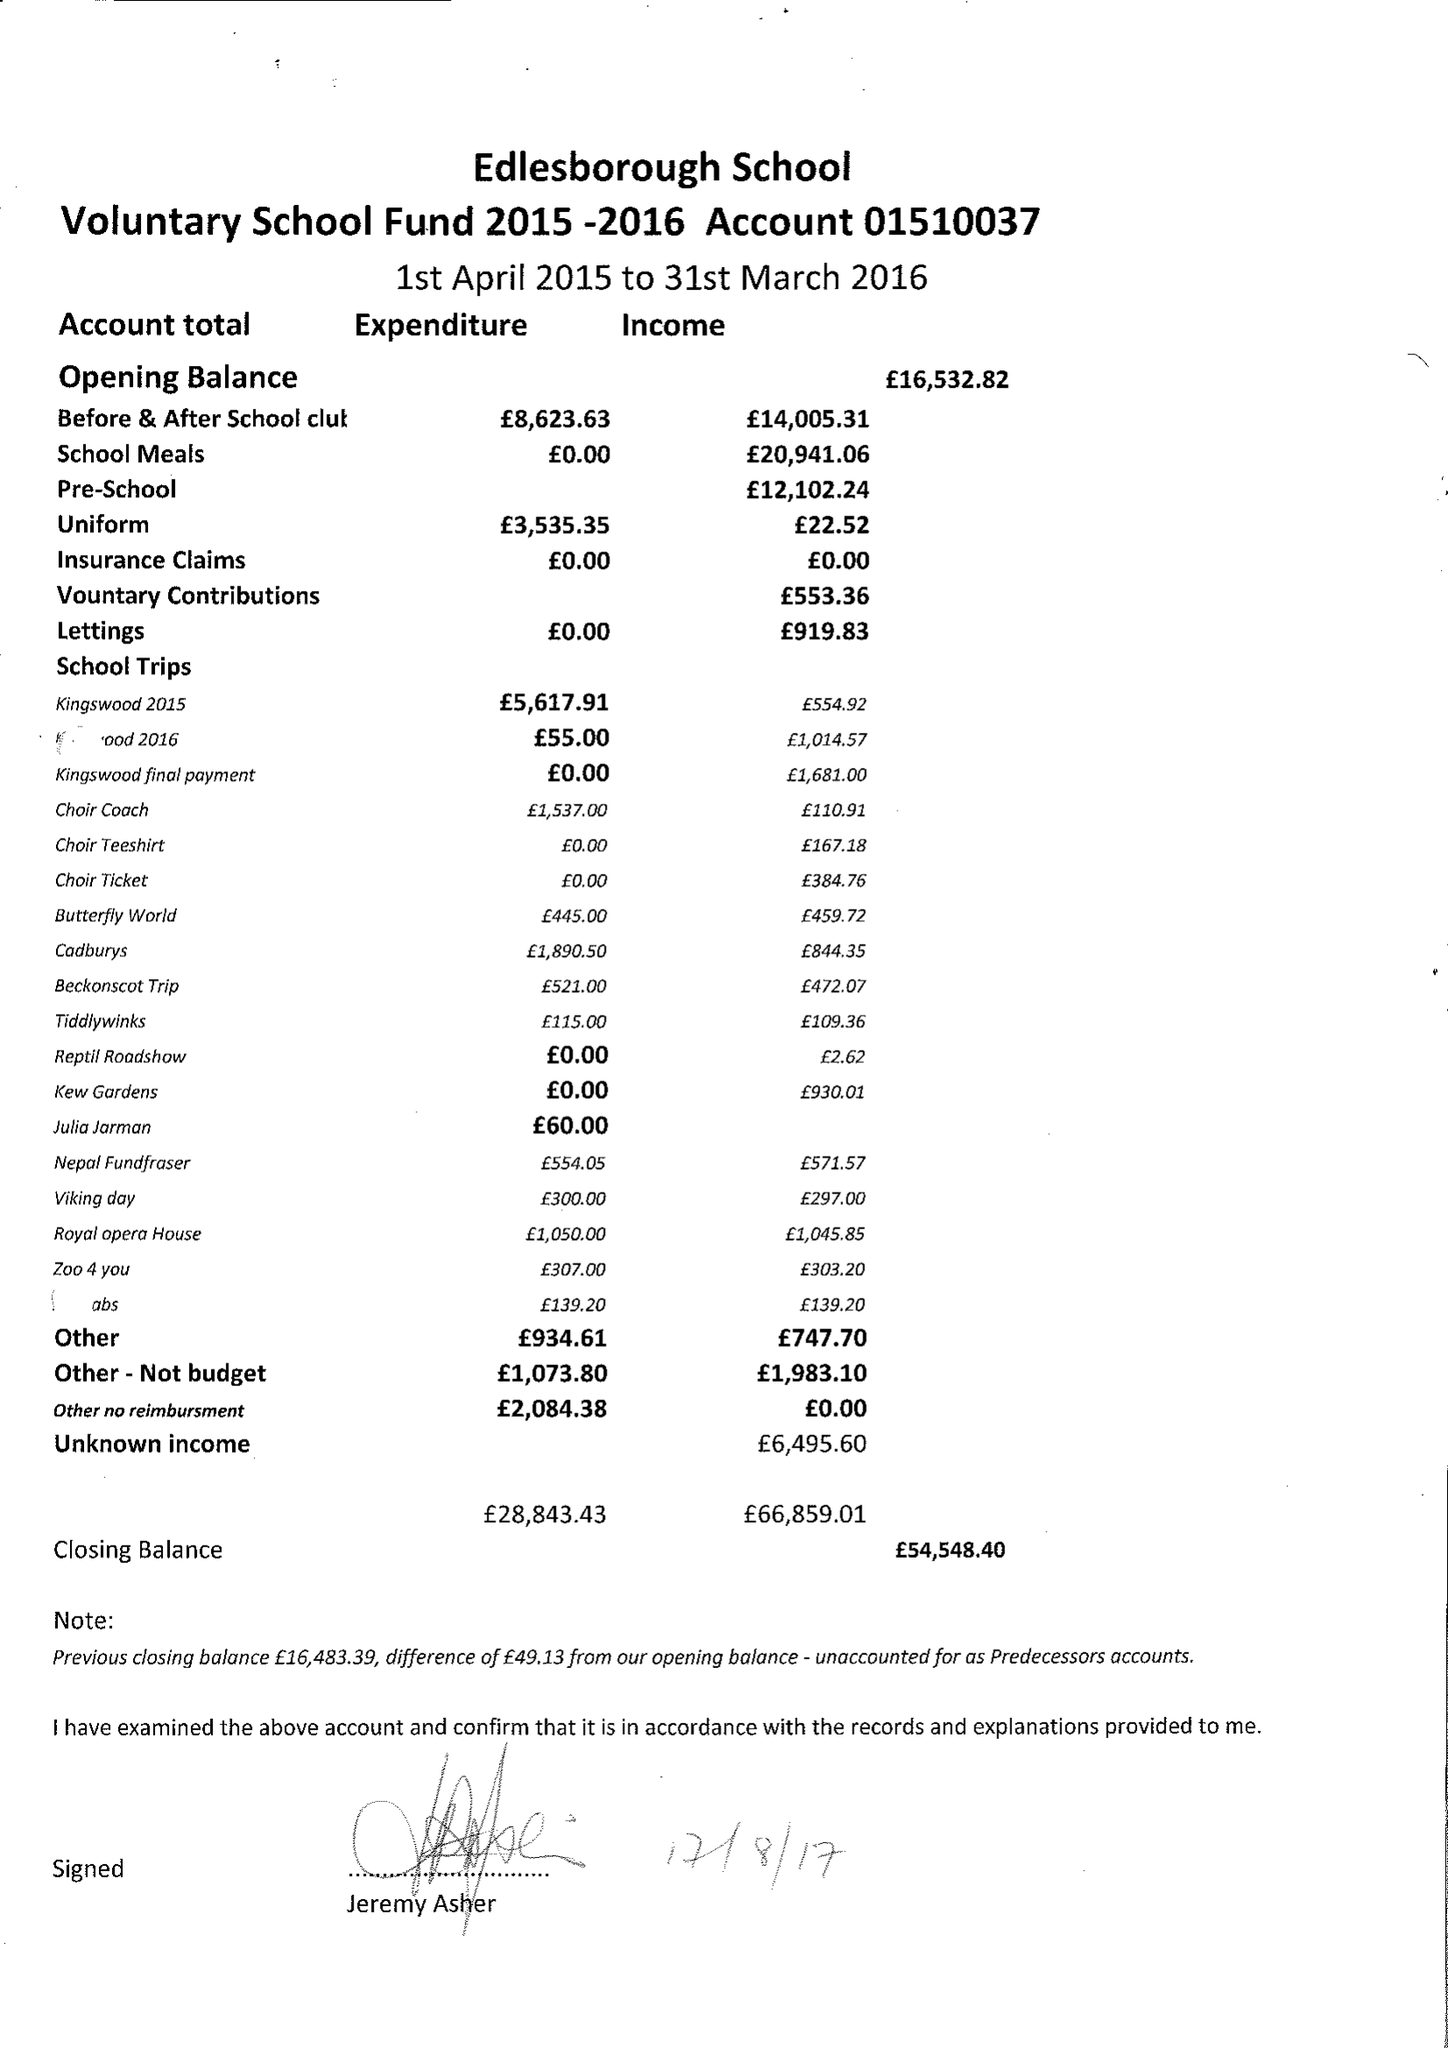What is the value for the income_annually_in_british_pounds?
Answer the question using a single word or phrase. 66859.01 